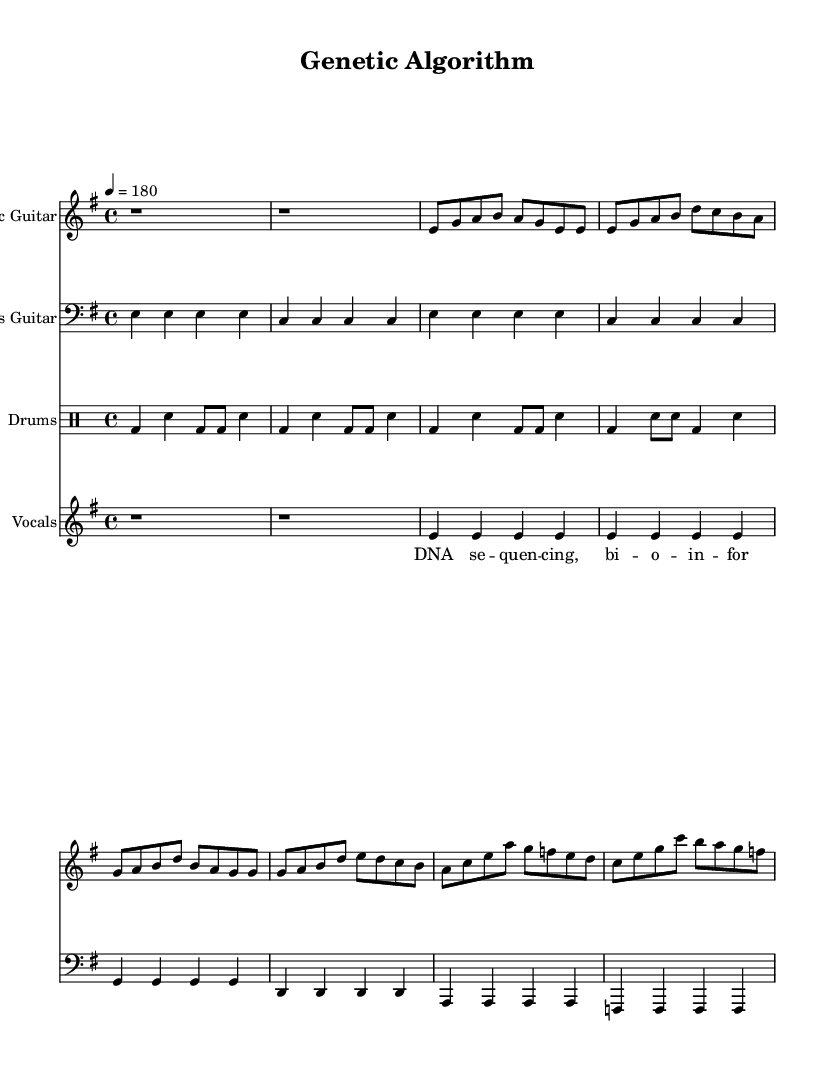What is the key signature of this music? The key signature is indicated at the beginning, showing two sharps (F# and C#). This corresponds to E minor, as it has the associated accidentals noted.
Answer: E minor What is the time signature of this piece? The time signature appears at the beginning of the score and is noted as 4/4, which means there are four beats in a measure and the quarter note gets one beat.
Answer: 4/4 What is the tempo marking of the piece? The tempo marking is specified as "4 = 180", indicating that the quarter note should be played at a speed of 180 beats per minute. This makes the music fast-paced, typical of punk rock.
Answer: 180 How many bars are in the verse section? By examining the verse part of the electric guitar, it consists of two bars of music, as shown by the notation of eight eighth notes divided into two measures.
Answer: 2 Which instrument plays the bass line? The bass line is played by the bass guitar, which is indicated by the clef and instrument name at the start of its staff.
Answer: Bass Guitar What type of rhythm is predominantly used in the drum part? The drum part consists of a basic punk beat, which is a simple and driving rhythm crucial to punk rock music, characterized by bass drum and snare placements.
Answer: Basic punk beat What is the theme of the lyrics in this piece? The lyrics suggest a theme of DNA sequencing and bioinformatics, as evidenced by the phrases referencing genetic algorithms and sequencing processes, reflective of a collaboration between computer science and biology.
Answer: DNA sequencing 